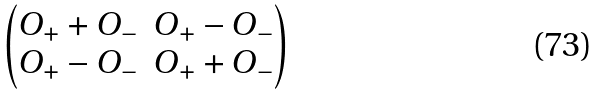<formula> <loc_0><loc_0><loc_500><loc_500>\begin{pmatrix} O _ { + } + O _ { - } & O _ { + } - O _ { - } \\ O _ { + } - O _ { - } & O _ { + } + O _ { - } \end{pmatrix}</formula> 